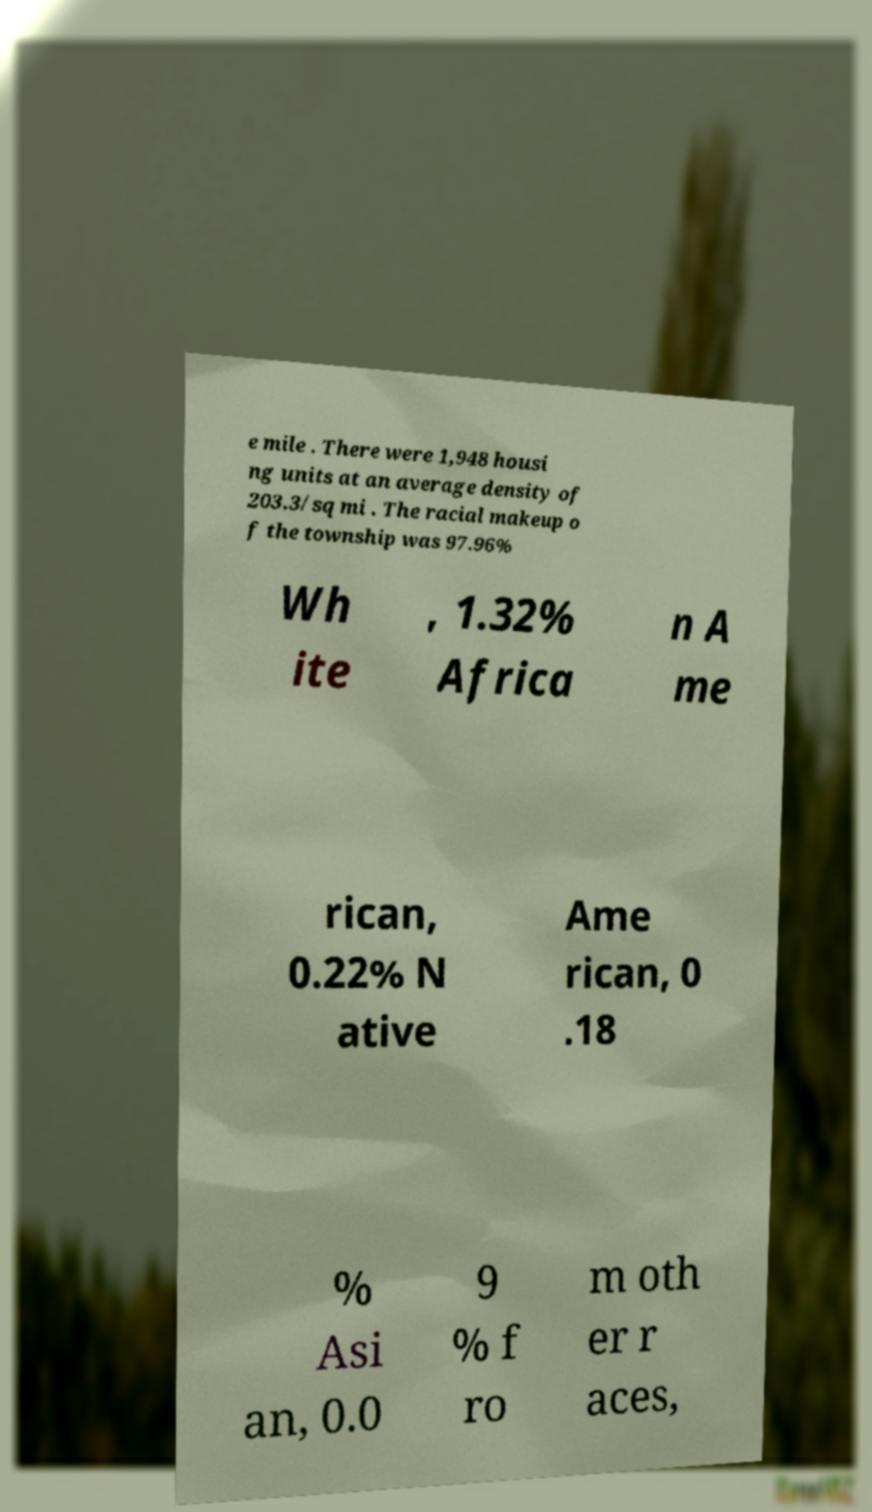I need the written content from this picture converted into text. Can you do that? e mile . There were 1,948 housi ng units at an average density of 203.3/sq mi . The racial makeup o f the township was 97.96% Wh ite , 1.32% Africa n A me rican, 0.22% N ative Ame rican, 0 .18 % Asi an, 0.0 9 % f ro m oth er r aces, 